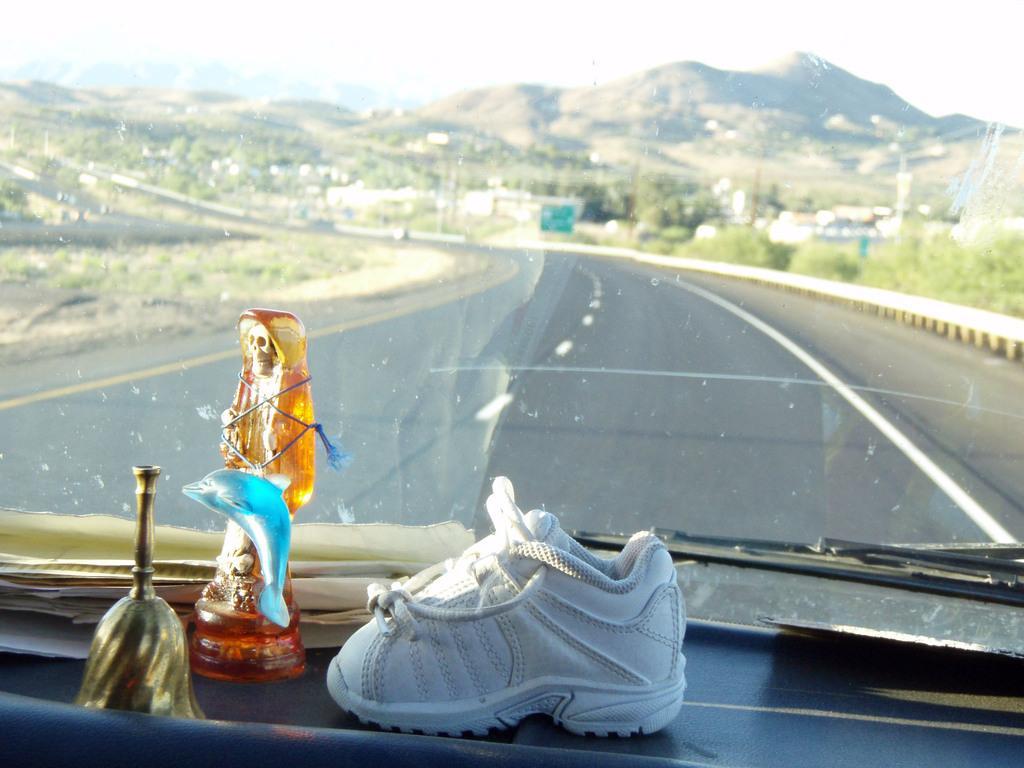Could you give a brief overview of what you see in this image? In this image I can see a picture which is taken from inside the vehicle. I can see a statue, a small shoe, the windshield, and wiper and through the windshield of the vehicle I can see the road, few trees, few buildings, few mountains and the sky. 